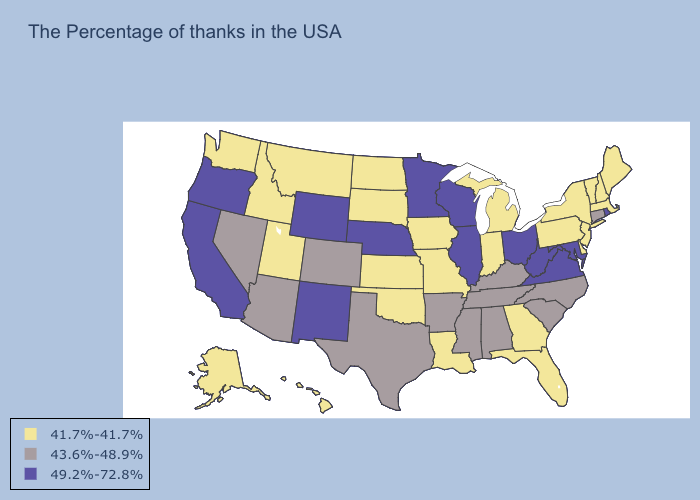What is the lowest value in the South?
Answer briefly. 41.7%-41.7%. What is the value of Indiana?
Keep it brief. 41.7%-41.7%. Name the states that have a value in the range 43.6%-48.9%?
Short answer required. Connecticut, North Carolina, South Carolina, Kentucky, Alabama, Tennessee, Mississippi, Arkansas, Texas, Colorado, Arizona, Nevada. Does the first symbol in the legend represent the smallest category?
Keep it brief. Yes. Does Connecticut have the lowest value in the Northeast?
Answer briefly. No. Name the states that have a value in the range 41.7%-41.7%?
Answer briefly. Maine, Massachusetts, New Hampshire, Vermont, New York, New Jersey, Delaware, Pennsylvania, Florida, Georgia, Michigan, Indiana, Louisiana, Missouri, Iowa, Kansas, Oklahoma, South Dakota, North Dakota, Utah, Montana, Idaho, Washington, Alaska, Hawaii. Name the states that have a value in the range 43.6%-48.9%?
Be succinct. Connecticut, North Carolina, South Carolina, Kentucky, Alabama, Tennessee, Mississippi, Arkansas, Texas, Colorado, Arizona, Nevada. Does Illinois have the lowest value in the USA?
Be succinct. No. Does New Hampshire have a lower value than Missouri?
Write a very short answer. No. What is the value of Indiana?
Write a very short answer. 41.7%-41.7%. Which states have the lowest value in the USA?
Give a very brief answer. Maine, Massachusetts, New Hampshire, Vermont, New York, New Jersey, Delaware, Pennsylvania, Florida, Georgia, Michigan, Indiana, Louisiana, Missouri, Iowa, Kansas, Oklahoma, South Dakota, North Dakota, Utah, Montana, Idaho, Washington, Alaska, Hawaii. What is the lowest value in states that border Oregon?
Write a very short answer. 41.7%-41.7%. Is the legend a continuous bar?
Keep it brief. No. Does Maine have a lower value than Montana?
Quick response, please. No. Among the states that border Vermont , which have the highest value?
Write a very short answer. Massachusetts, New Hampshire, New York. 